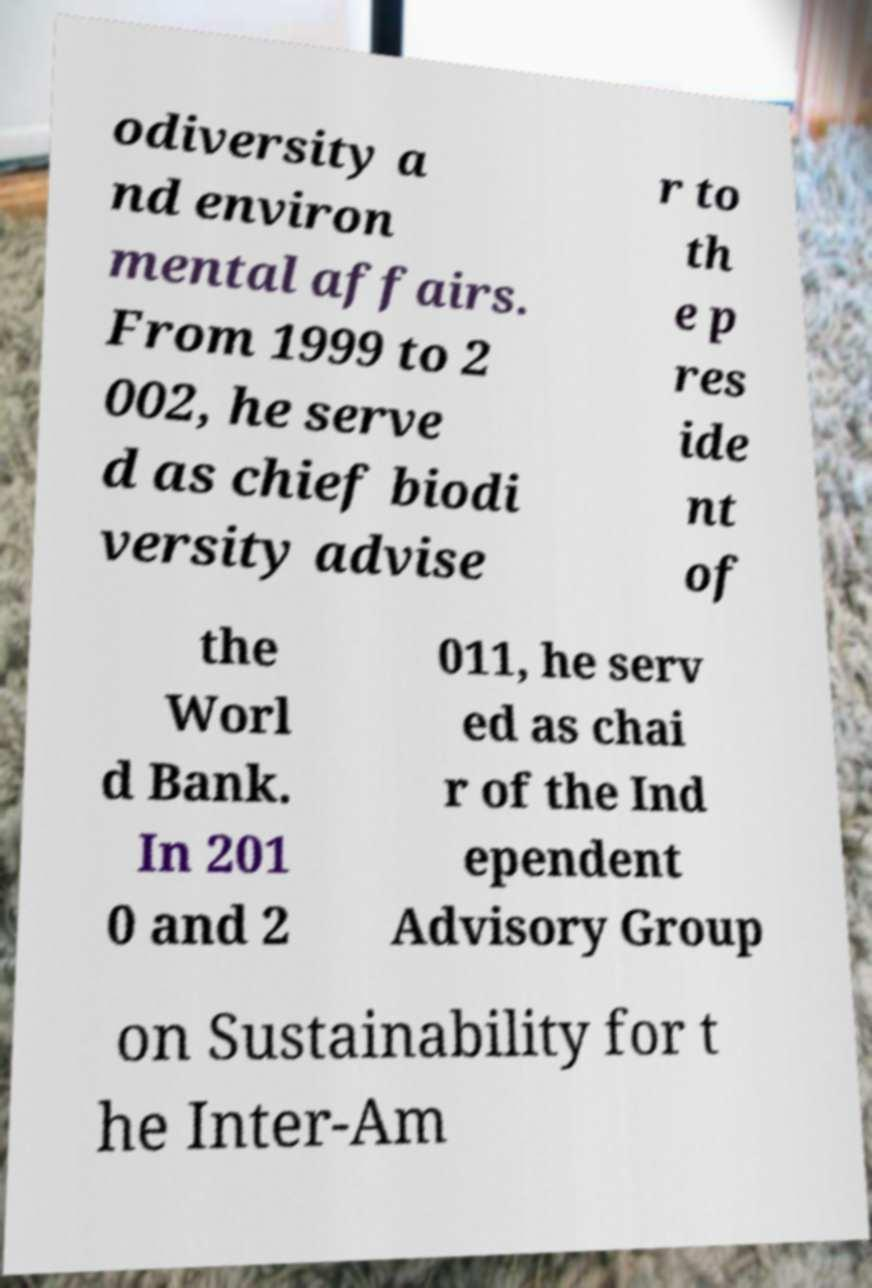I need the written content from this picture converted into text. Can you do that? odiversity a nd environ mental affairs. From 1999 to 2 002, he serve d as chief biodi versity advise r to th e p res ide nt of the Worl d Bank. In 201 0 and 2 011, he serv ed as chai r of the Ind ependent Advisory Group on Sustainability for t he Inter-Am 